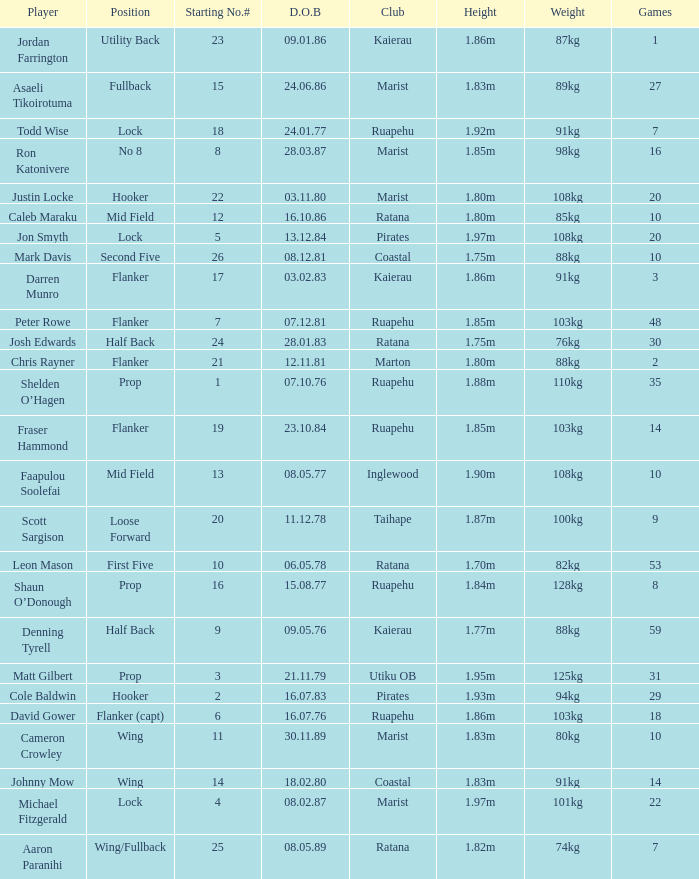Would you be able to parse every entry in this table? {'header': ['Player', 'Position', 'Starting No.#', 'D.O.B', 'Club', 'Height', 'Weight', 'Games'], 'rows': [['Jordan Farrington', 'Utility Back', '23', '09.01.86', 'Kaierau', '1.86m', '87kg', '1'], ['Asaeli Tikoirotuma', 'Fullback', '15', '24.06.86', 'Marist', '1.83m', '89kg', '27'], ['Todd Wise', 'Lock', '18', '24.01.77', 'Ruapehu', '1.92m', '91kg', '7'], ['Ron Katonivere', 'No 8', '8', '28.03.87', 'Marist', '1.85m', '98kg', '16'], ['Justin Locke', 'Hooker', '22', '03.11.80', 'Marist', '1.80m', '108kg', '20'], ['Caleb Maraku', 'Mid Field', '12', '16.10.86', 'Ratana', '1.80m', '85kg', '10'], ['Jon Smyth', 'Lock', '5', '13.12.84', 'Pirates', '1.97m', '108kg', '20'], ['Mark Davis', 'Second Five', '26', '08.12.81', 'Coastal', '1.75m', '88kg', '10'], ['Darren Munro', 'Flanker', '17', '03.02.83', 'Kaierau', '1.86m', '91kg', '3'], ['Peter Rowe', 'Flanker', '7', '07.12.81', 'Ruapehu', '1.85m', '103kg', '48'], ['Josh Edwards', 'Half Back', '24', '28.01.83', 'Ratana', '1.75m', '76kg', '30'], ['Chris Rayner', 'Flanker', '21', '12.11.81', 'Marton', '1.80m', '88kg', '2'], ['Shelden O’Hagen', 'Prop', '1', '07.10.76', 'Ruapehu', '1.88m', '110kg', '35'], ['Fraser Hammond', 'Flanker', '19', '23.10.84', 'Ruapehu', '1.85m', '103kg', '14'], ['Faapulou Soolefai', 'Mid Field', '13', '08.05.77', 'Inglewood', '1.90m', '108kg', '10'], ['Scott Sargison', 'Loose Forward', '20', '11.12.78', 'Taihape', '1.87m', '100kg', '9'], ['Leon Mason', 'First Five', '10', '06.05.78', 'Ratana', '1.70m', '82kg', '53'], ['Shaun O’Donough', 'Prop', '16', '15.08.77', 'Ruapehu', '1.84m', '128kg', '8'], ['Denning Tyrell', 'Half Back', '9', '09.05.76', 'Kaierau', '1.77m', '88kg', '59'], ['Matt Gilbert', 'Prop', '3', '21.11.79', 'Utiku OB', '1.95m', '125kg', '31'], ['Cole Baldwin', 'Hooker', '2', '16.07.83', 'Pirates', '1.93m', '94kg', '29'], ['David Gower', 'Flanker (capt)', '6', '16.07.76', 'Ruapehu', '1.86m', '103kg', '18'], ['Cameron Crowley', 'Wing', '11', '30.11.89', 'Marist', '1.83m', '80kg', '10'], ['Johnny Mow', 'Wing', '14', '18.02.80', 'Coastal', '1.83m', '91kg', '14'], ['Michael Fitzgerald', 'Lock', '4', '08.02.87', 'Marist', '1.97m', '101kg', '22'], ['Aaron Paranihi', 'Wing/Fullback', '25', '08.05.89', 'Ratana', '1.82m', '74kg', '7']]} How many games were played where the height of the player is 1.92m? 1.0. 